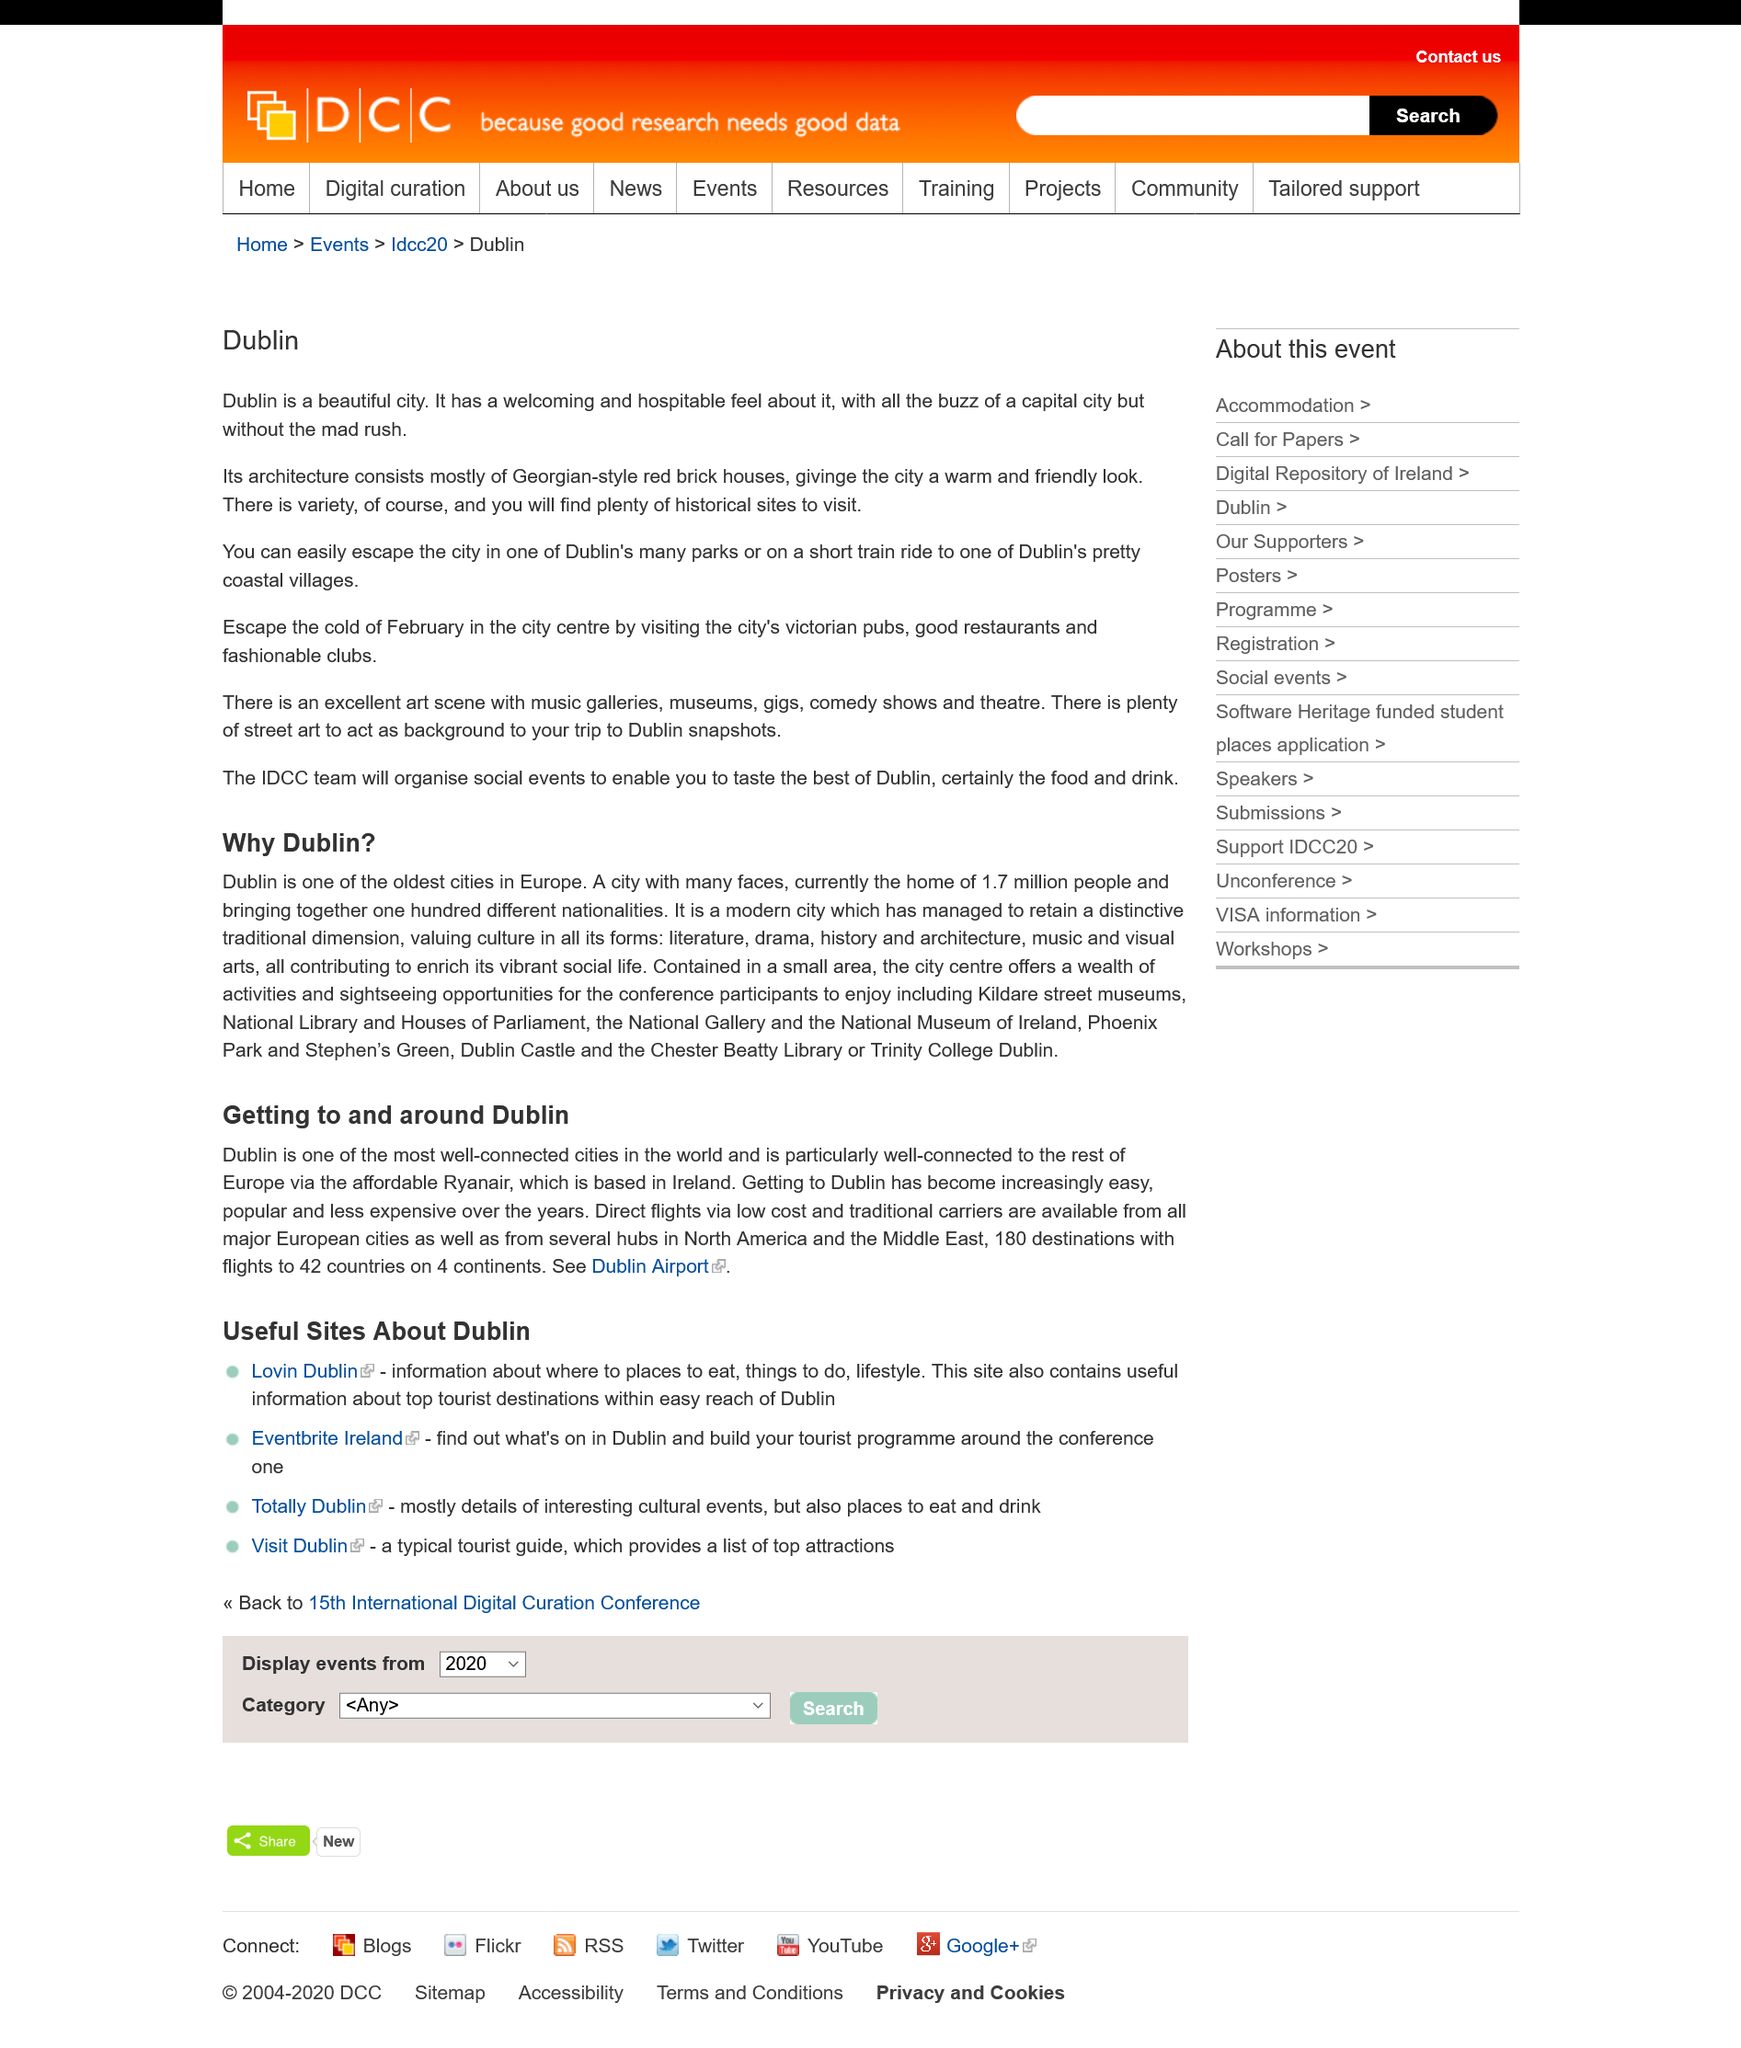Highlight a few significant elements in this photo. Dublin possesses a warm and inviting aesthetic, as well as the lively and energetic atmosphere of a bustling capital city. It is estimated that 1.7 million people call Dublin their home. Dublin has a large number of parks, which can be seen as a testament to the city's commitment to providing its residents and visitors with access to green spaces and outdoor recreational areas. These parks offer a range of facilities and amenities, including walking trails, playgrounds, sports fields, and picnic areas, making them popular destinations for families, fitness enthusiasts, and nature lovers alike. With such a vast array of parks to choose from, it's clear that Dublin is a city that values the importance of green spaces and the role they play in promoting health, well-being, and community engagement. Dublin is one of the oldest cities in Europe, and this fact is a significant part of the answer to why Dublin has become a popular travel destination. Dublin has retained a distinctive traditional dimension, as evidenced by the city's ability to preserve and celebrate its rich cultural heritage. 